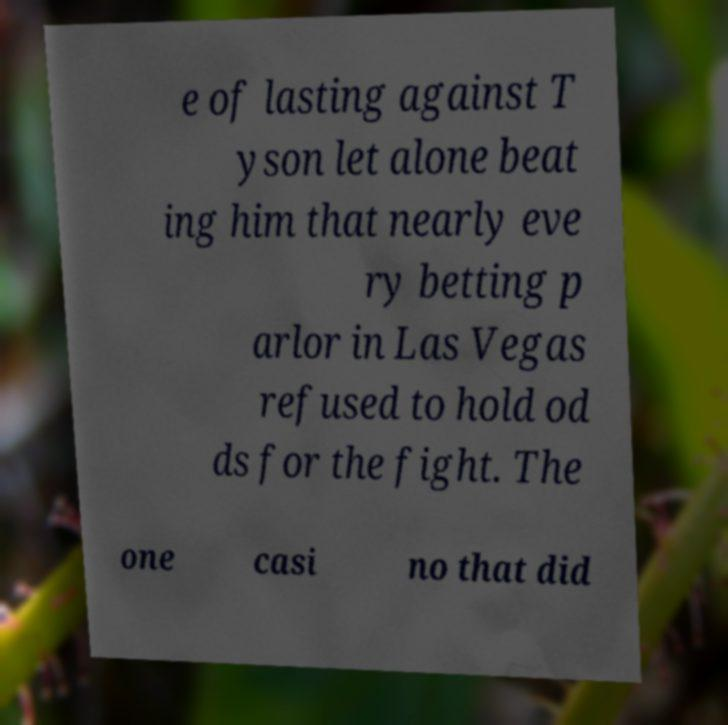I need the written content from this picture converted into text. Can you do that? e of lasting against T yson let alone beat ing him that nearly eve ry betting p arlor in Las Vegas refused to hold od ds for the fight. The one casi no that did 